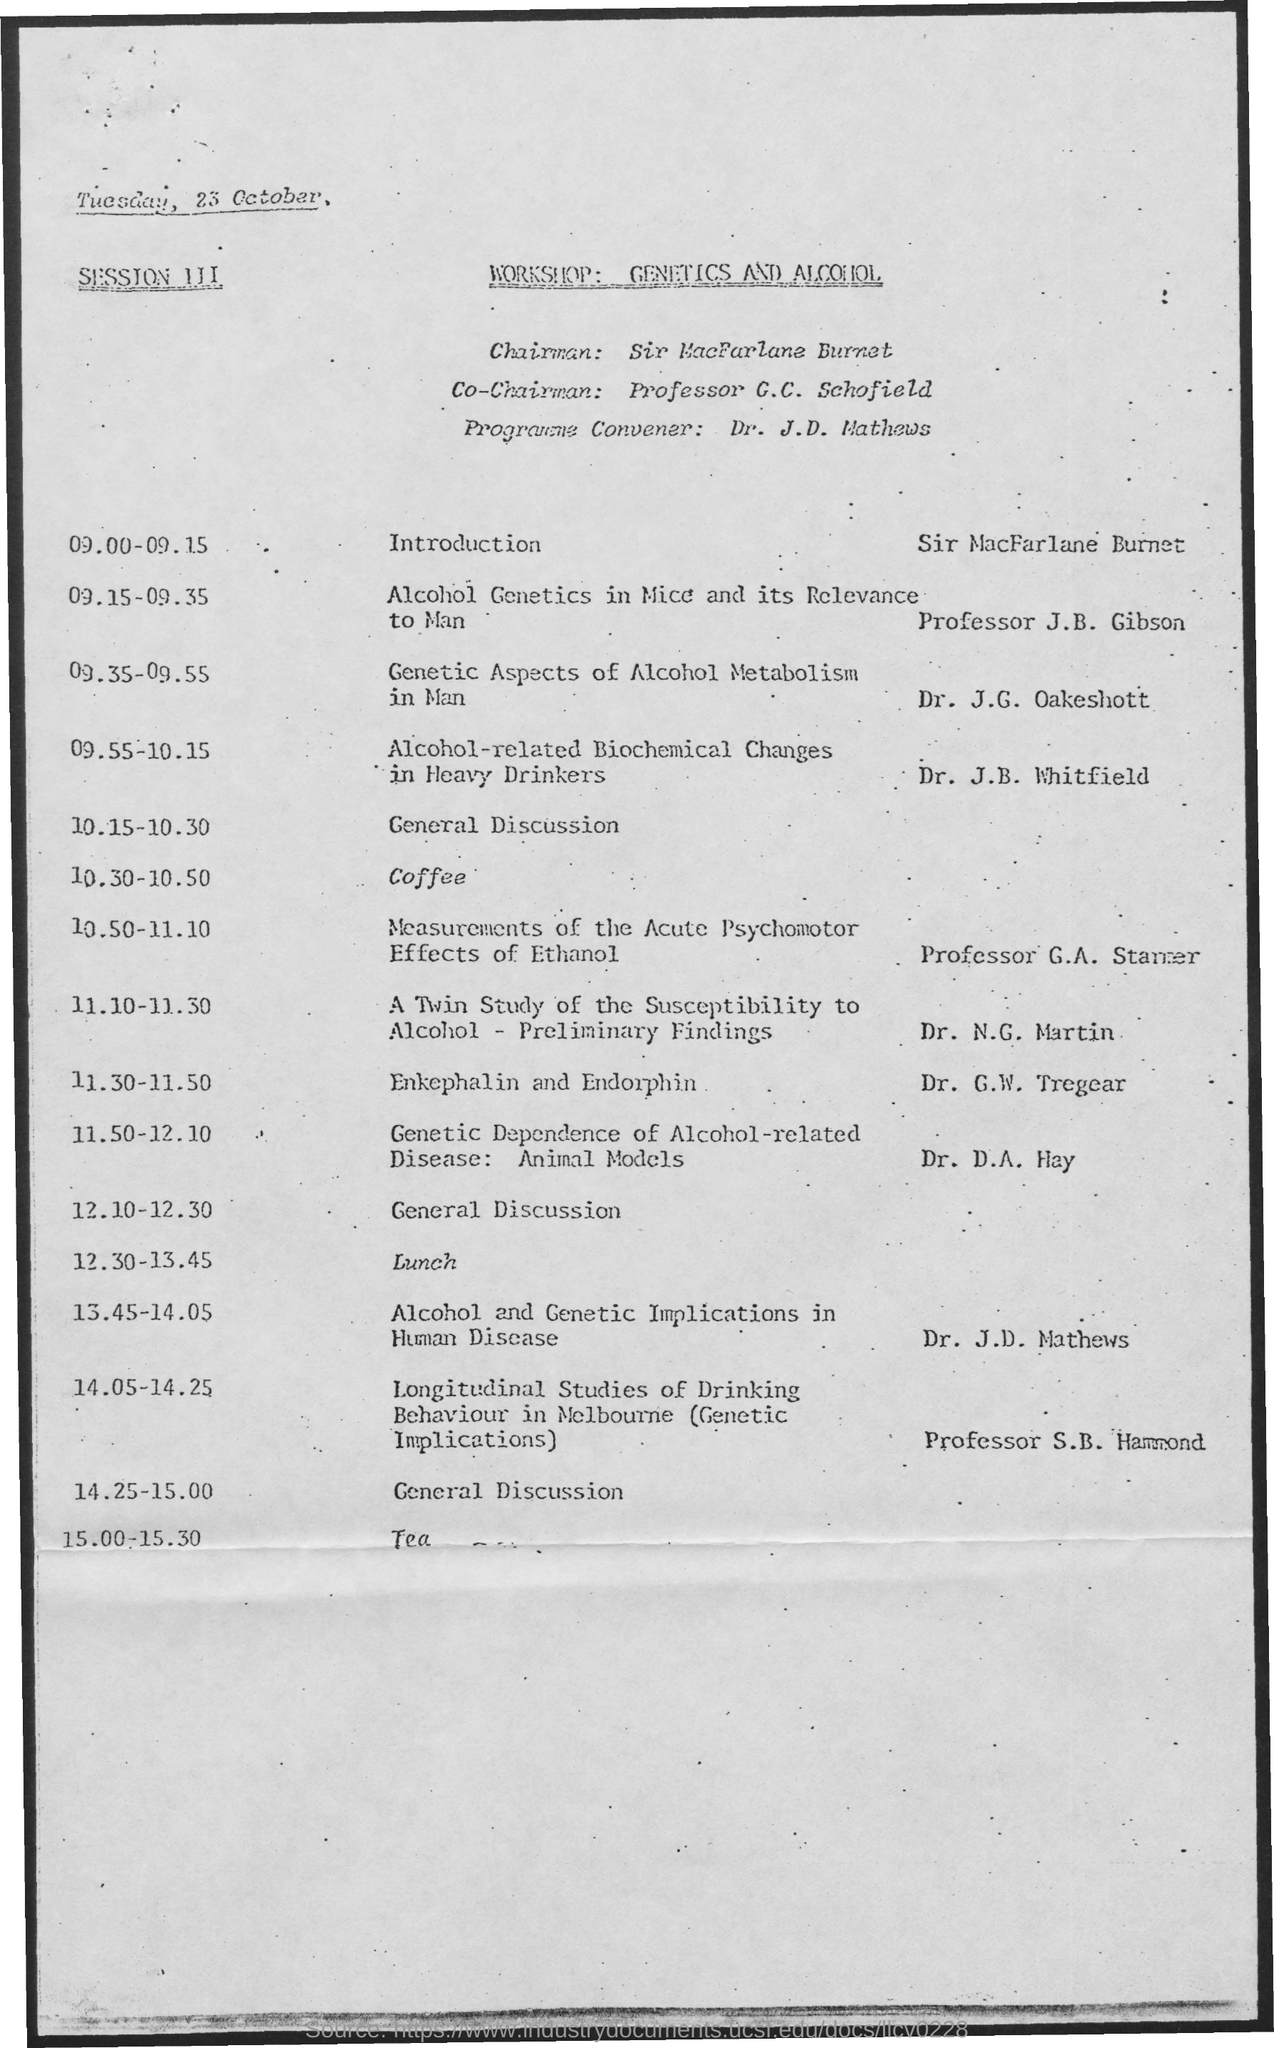Draw attention to some important aspects in this diagram. The schedule at 10:30-10:50, as mentioned in the given agenda, is for coffee. At 10.15-10.30 as mentioned in the given agenda, the schedule is as follows: General Discussion will take place. The program convener for the given workshop is Dr. J.D. Mathews. The chairman of the given workshop is Sir MacfArlane Burnett. The schedule at the time of 12:30-13:45, as mentioned in the given agenda, includes lunch. 